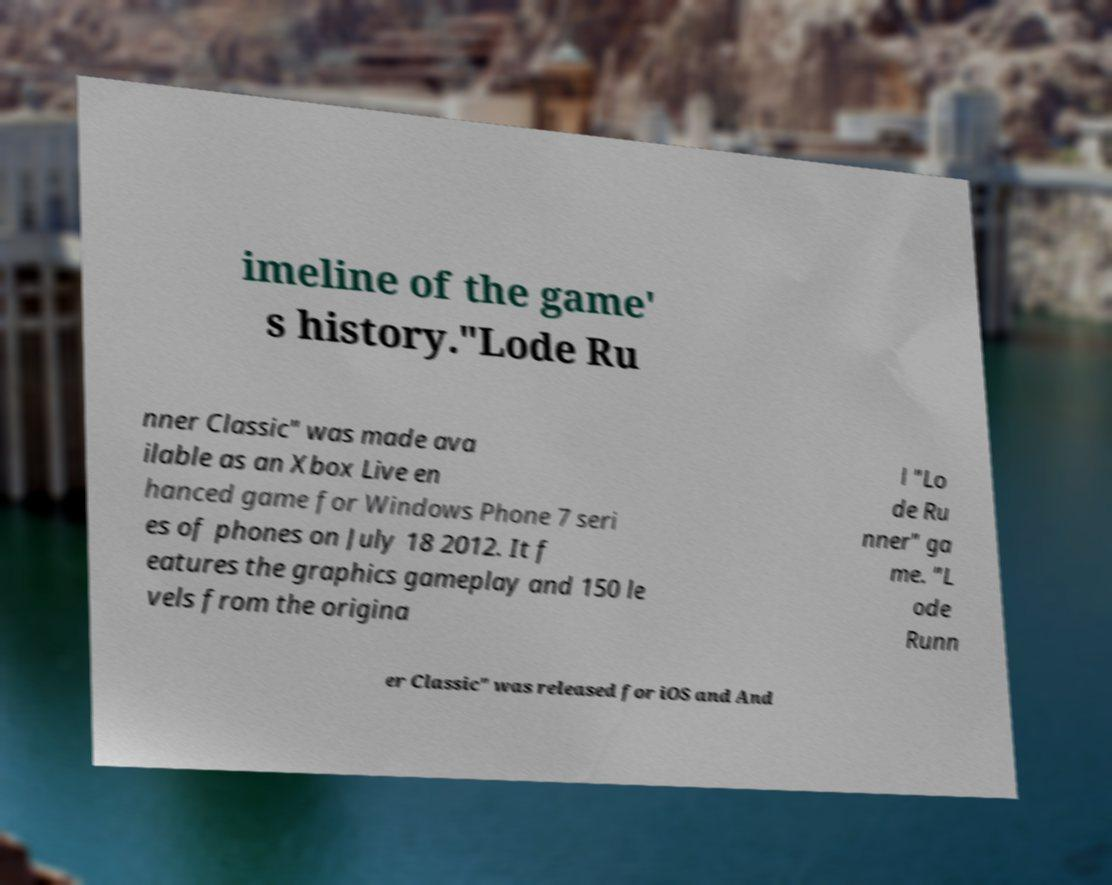Could you assist in decoding the text presented in this image and type it out clearly? imeline of the game' s history."Lode Ru nner Classic" was made ava ilable as an Xbox Live en hanced game for Windows Phone 7 seri es of phones on July 18 2012. It f eatures the graphics gameplay and 150 le vels from the origina l "Lo de Ru nner" ga me. "L ode Runn er Classic" was released for iOS and And 